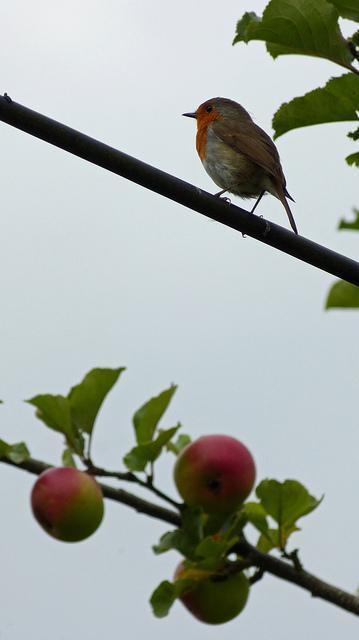How many apples are there?
Give a very brief answer. 3. How many levels are there in the bus to the right?
Give a very brief answer. 0. 